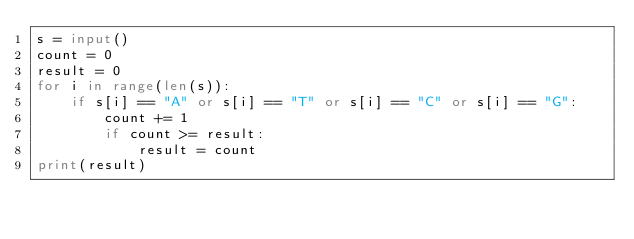<code> <loc_0><loc_0><loc_500><loc_500><_Python_>s = input()
count = 0
result = 0
for i in range(len(s)):
    if s[i] == "A" or s[i] == "T" or s[i] == "C" or s[i] == "G":
        count += 1
        if count >= result:
            result = count
print(result)</code> 